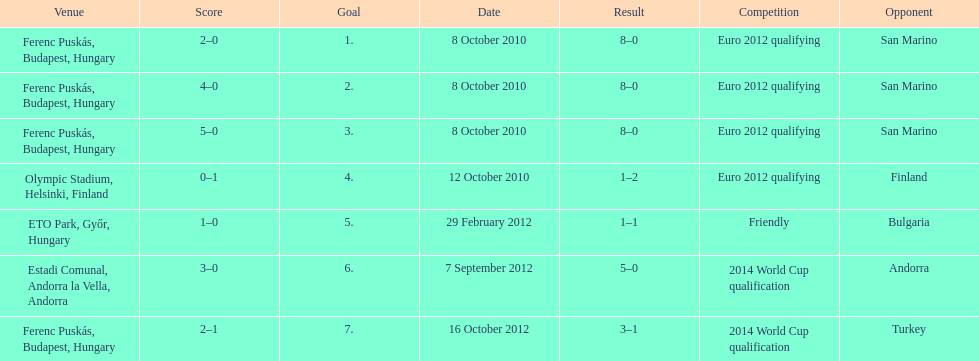What is the sum of goals made in the euro 2012 qualifying event? 12. 